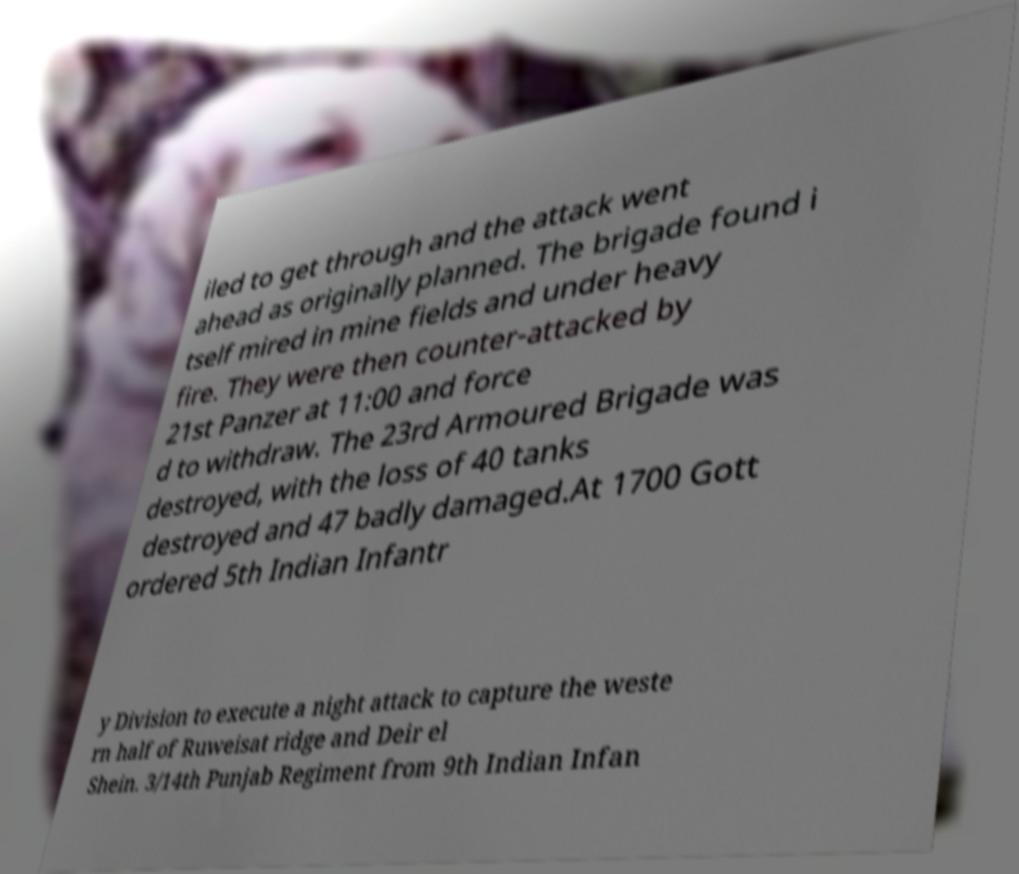Can you accurately transcribe the text from the provided image for me? iled to get through and the attack went ahead as originally planned. The brigade found i tself mired in mine fields and under heavy fire. They were then counter-attacked by 21st Panzer at 11:00 and force d to withdraw. The 23rd Armoured Brigade was destroyed, with the loss of 40 tanks destroyed and 47 badly damaged.At 1700 Gott ordered 5th Indian Infantr y Division to execute a night attack to capture the weste rn half of Ruweisat ridge and Deir el Shein. 3/14th Punjab Regiment from 9th Indian Infan 